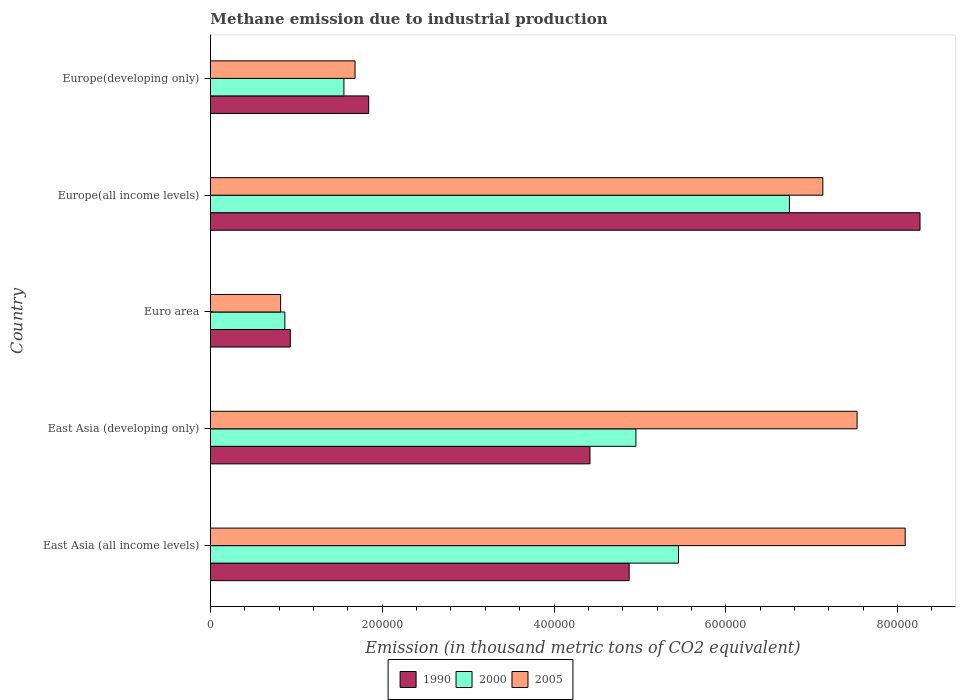How many different coloured bars are there?
Offer a terse response. 3. Are the number of bars on each tick of the Y-axis equal?
Offer a very short reply. Yes. How many bars are there on the 2nd tick from the top?
Offer a very short reply. 3. How many bars are there on the 1st tick from the bottom?
Your answer should be compact. 3. What is the label of the 2nd group of bars from the top?
Offer a very short reply. Europe(all income levels). What is the amount of methane emitted in 1990 in Europe(all income levels)?
Provide a short and direct response. 8.26e+05. Across all countries, what is the maximum amount of methane emitted in 1990?
Offer a terse response. 8.26e+05. Across all countries, what is the minimum amount of methane emitted in 2000?
Provide a short and direct response. 8.66e+04. In which country was the amount of methane emitted in 1990 maximum?
Your answer should be very brief. Europe(all income levels). What is the total amount of methane emitted in 2000 in the graph?
Make the answer very short. 1.96e+06. What is the difference between the amount of methane emitted in 2005 in Europe(all income levels) and that in Europe(developing only)?
Your answer should be compact. 5.45e+05. What is the difference between the amount of methane emitted in 1990 in Euro area and the amount of methane emitted in 2000 in East Asia (all income levels)?
Your answer should be compact. -4.52e+05. What is the average amount of methane emitted in 2000 per country?
Keep it short and to the point. 3.91e+05. What is the difference between the amount of methane emitted in 2005 and amount of methane emitted in 2000 in Euro area?
Your answer should be very brief. -4908.4. In how many countries, is the amount of methane emitted in 1990 greater than 680000 thousand metric tons?
Provide a short and direct response. 1. What is the ratio of the amount of methane emitted in 2000 in East Asia (developing only) to that in Europe(all income levels)?
Your answer should be very brief. 0.73. Is the difference between the amount of methane emitted in 2005 in East Asia (all income levels) and Europe(developing only) greater than the difference between the amount of methane emitted in 2000 in East Asia (all income levels) and Europe(developing only)?
Offer a terse response. Yes. What is the difference between the highest and the second highest amount of methane emitted in 2005?
Give a very brief answer. 5.60e+04. What is the difference between the highest and the lowest amount of methane emitted in 1990?
Your answer should be compact. 7.33e+05. In how many countries, is the amount of methane emitted in 2000 greater than the average amount of methane emitted in 2000 taken over all countries?
Offer a very short reply. 3. What does the 3rd bar from the bottom in Euro area represents?
Ensure brevity in your answer.  2005. How many bars are there?
Give a very brief answer. 15. What is the difference between two consecutive major ticks on the X-axis?
Keep it short and to the point. 2.00e+05. Are the values on the major ticks of X-axis written in scientific E-notation?
Offer a terse response. No. Does the graph contain any zero values?
Provide a succinct answer. No. Does the graph contain grids?
Offer a terse response. No. Where does the legend appear in the graph?
Provide a short and direct response. Bottom center. How many legend labels are there?
Make the answer very short. 3. What is the title of the graph?
Ensure brevity in your answer.  Methane emission due to industrial production. Does "1962" appear as one of the legend labels in the graph?
Give a very brief answer. No. What is the label or title of the X-axis?
Provide a succinct answer. Emission (in thousand metric tons of CO2 equivalent). What is the Emission (in thousand metric tons of CO2 equivalent) in 1990 in East Asia (all income levels)?
Keep it short and to the point. 4.88e+05. What is the Emission (in thousand metric tons of CO2 equivalent) of 2000 in East Asia (all income levels)?
Keep it short and to the point. 5.45e+05. What is the Emission (in thousand metric tons of CO2 equivalent) of 2005 in East Asia (all income levels)?
Provide a succinct answer. 8.09e+05. What is the Emission (in thousand metric tons of CO2 equivalent) in 1990 in East Asia (developing only)?
Keep it short and to the point. 4.42e+05. What is the Emission (in thousand metric tons of CO2 equivalent) in 2000 in East Asia (developing only)?
Provide a short and direct response. 4.95e+05. What is the Emission (in thousand metric tons of CO2 equivalent) of 2005 in East Asia (developing only)?
Keep it short and to the point. 7.53e+05. What is the Emission (in thousand metric tons of CO2 equivalent) of 1990 in Euro area?
Provide a succinct answer. 9.30e+04. What is the Emission (in thousand metric tons of CO2 equivalent) of 2000 in Euro area?
Provide a short and direct response. 8.66e+04. What is the Emission (in thousand metric tons of CO2 equivalent) in 2005 in Euro area?
Offer a terse response. 8.17e+04. What is the Emission (in thousand metric tons of CO2 equivalent) of 1990 in Europe(all income levels)?
Ensure brevity in your answer.  8.26e+05. What is the Emission (in thousand metric tons of CO2 equivalent) in 2000 in Europe(all income levels)?
Make the answer very short. 6.74e+05. What is the Emission (in thousand metric tons of CO2 equivalent) of 2005 in Europe(all income levels)?
Give a very brief answer. 7.13e+05. What is the Emission (in thousand metric tons of CO2 equivalent) of 1990 in Europe(developing only)?
Give a very brief answer. 1.84e+05. What is the Emission (in thousand metric tons of CO2 equivalent) of 2000 in Europe(developing only)?
Offer a terse response. 1.55e+05. What is the Emission (in thousand metric tons of CO2 equivalent) in 2005 in Europe(developing only)?
Provide a succinct answer. 1.68e+05. Across all countries, what is the maximum Emission (in thousand metric tons of CO2 equivalent) of 1990?
Provide a short and direct response. 8.26e+05. Across all countries, what is the maximum Emission (in thousand metric tons of CO2 equivalent) in 2000?
Offer a terse response. 6.74e+05. Across all countries, what is the maximum Emission (in thousand metric tons of CO2 equivalent) in 2005?
Your response must be concise. 8.09e+05. Across all countries, what is the minimum Emission (in thousand metric tons of CO2 equivalent) of 1990?
Keep it short and to the point. 9.30e+04. Across all countries, what is the minimum Emission (in thousand metric tons of CO2 equivalent) of 2000?
Offer a very short reply. 8.66e+04. Across all countries, what is the minimum Emission (in thousand metric tons of CO2 equivalent) in 2005?
Provide a short and direct response. 8.17e+04. What is the total Emission (in thousand metric tons of CO2 equivalent) in 1990 in the graph?
Ensure brevity in your answer.  2.03e+06. What is the total Emission (in thousand metric tons of CO2 equivalent) of 2000 in the graph?
Provide a succinct answer. 1.96e+06. What is the total Emission (in thousand metric tons of CO2 equivalent) of 2005 in the graph?
Give a very brief answer. 2.52e+06. What is the difference between the Emission (in thousand metric tons of CO2 equivalent) in 1990 in East Asia (all income levels) and that in East Asia (developing only)?
Offer a terse response. 4.56e+04. What is the difference between the Emission (in thousand metric tons of CO2 equivalent) in 2000 in East Asia (all income levels) and that in East Asia (developing only)?
Make the answer very short. 4.96e+04. What is the difference between the Emission (in thousand metric tons of CO2 equivalent) in 2005 in East Asia (all income levels) and that in East Asia (developing only)?
Your response must be concise. 5.60e+04. What is the difference between the Emission (in thousand metric tons of CO2 equivalent) of 1990 in East Asia (all income levels) and that in Euro area?
Ensure brevity in your answer.  3.95e+05. What is the difference between the Emission (in thousand metric tons of CO2 equivalent) in 2000 in East Asia (all income levels) and that in Euro area?
Give a very brief answer. 4.58e+05. What is the difference between the Emission (in thousand metric tons of CO2 equivalent) in 2005 in East Asia (all income levels) and that in Euro area?
Ensure brevity in your answer.  7.27e+05. What is the difference between the Emission (in thousand metric tons of CO2 equivalent) in 1990 in East Asia (all income levels) and that in Europe(all income levels)?
Your answer should be compact. -3.39e+05. What is the difference between the Emission (in thousand metric tons of CO2 equivalent) in 2000 in East Asia (all income levels) and that in Europe(all income levels)?
Provide a short and direct response. -1.29e+05. What is the difference between the Emission (in thousand metric tons of CO2 equivalent) of 2005 in East Asia (all income levels) and that in Europe(all income levels)?
Give a very brief answer. 9.59e+04. What is the difference between the Emission (in thousand metric tons of CO2 equivalent) in 1990 in East Asia (all income levels) and that in Europe(developing only)?
Offer a very short reply. 3.03e+05. What is the difference between the Emission (in thousand metric tons of CO2 equivalent) of 2000 in East Asia (all income levels) and that in Europe(developing only)?
Your answer should be compact. 3.90e+05. What is the difference between the Emission (in thousand metric tons of CO2 equivalent) in 2005 in East Asia (all income levels) and that in Europe(developing only)?
Your answer should be compact. 6.41e+05. What is the difference between the Emission (in thousand metric tons of CO2 equivalent) of 1990 in East Asia (developing only) and that in Euro area?
Provide a short and direct response. 3.49e+05. What is the difference between the Emission (in thousand metric tons of CO2 equivalent) in 2000 in East Asia (developing only) and that in Euro area?
Your answer should be very brief. 4.09e+05. What is the difference between the Emission (in thousand metric tons of CO2 equivalent) of 2005 in East Asia (developing only) and that in Euro area?
Provide a succinct answer. 6.71e+05. What is the difference between the Emission (in thousand metric tons of CO2 equivalent) in 1990 in East Asia (developing only) and that in Europe(all income levels)?
Your answer should be compact. -3.84e+05. What is the difference between the Emission (in thousand metric tons of CO2 equivalent) in 2000 in East Asia (developing only) and that in Europe(all income levels)?
Ensure brevity in your answer.  -1.79e+05. What is the difference between the Emission (in thousand metric tons of CO2 equivalent) of 2005 in East Asia (developing only) and that in Europe(all income levels)?
Your answer should be compact. 3.99e+04. What is the difference between the Emission (in thousand metric tons of CO2 equivalent) of 1990 in East Asia (developing only) and that in Europe(developing only)?
Keep it short and to the point. 2.58e+05. What is the difference between the Emission (in thousand metric tons of CO2 equivalent) of 2000 in East Asia (developing only) and that in Europe(developing only)?
Give a very brief answer. 3.40e+05. What is the difference between the Emission (in thousand metric tons of CO2 equivalent) in 2005 in East Asia (developing only) and that in Europe(developing only)?
Your answer should be very brief. 5.85e+05. What is the difference between the Emission (in thousand metric tons of CO2 equivalent) of 1990 in Euro area and that in Europe(all income levels)?
Make the answer very short. -7.33e+05. What is the difference between the Emission (in thousand metric tons of CO2 equivalent) in 2000 in Euro area and that in Europe(all income levels)?
Your response must be concise. -5.88e+05. What is the difference between the Emission (in thousand metric tons of CO2 equivalent) of 2005 in Euro area and that in Europe(all income levels)?
Your answer should be very brief. -6.31e+05. What is the difference between the Emission (in thousand metric tons of CO2 equivalent) in 1990 in Euro area and that in Europe(developing only)?
Provide a short and direct response. -9.13e+04. What is the difference between the Emission (in thousand metric tons of CO2 equivalent) in 2000 in Euro area and that in Europe(developing only)?
Ensure brevity in your answer.  -6.88e+04. What is the difference between the Emission (in thousand metric tons of CO2 equivalent) of 2005 in Euro area and that in Europe(developing only)?
Offer a very short reply. -8.66e+04. What is the difference between the Emission (in thousand metric tons of CO2 equivalent) of 1990 in Europe(all income levels) and that in Europe(developing only)?
Provide a short and direct response. 6.42e+05. What is the difference between the Emission (in thousand metric tons of CO2 equivalent) in 2000 in Europe(all income levels) and that in Europe(developing only)?
Your response must be concise. 5.19e+05. What is the difference between the Emission (in thousand metric tons of CO2 equivalent) of 2005 in Europe(all income levels) and that in Europe(developing only)?
Provide a succinct answer. 5.45e+05. What is the difference between the Emission (in thousand metric tons of CO2 equivalent) of 1990 in East Asia (all income levels) and the Emission (in thousand metric tons of CO2 equivalent) of 2000 in East Asia (developing only)?
Your answer should be very brief. -7879.1. What is the difference between the Emission (in thousand metric tons of CO2 equivalent) of 1990 in East Asia (all income levels) and the Emission (in thousand metric tons of CO2 equivalent) of 2005 in East Asia (developing only)?
Your response must be concise. -2.65e+05. What is the difference between the Emission (in thousand metric tons of CO2 equivalent) in 2000 in East Asia (all income levels) and the Emission (in thousand metric tons of CO2 equivalent) in 2005 in East Asia (developing only)?
Your response must be concise. -2.08e+05. What is the difference between the Emission (in thousand metric tons of CO2 equivalent) in 1990 in East Asia (all income levels) and the Emission (in thousand metric tons of CO2 equivalent) in 2000 in Euro area?
Your response must be concise. 4.01e+05. What is the difference between the Emission (in thousand metric tons of CO2 equivalent) of 1990 in East Asia (all income levels) and the Emission (in thousand metric tons of CO2 equivalent) of 2005 in Euro area?
Your response must be concise. 4.06e+05. What is the difference between the Emission (in thousand metric tons of CO2 equivalent) of 2000 in East Asia (all income levels) and the Emission (in thousand metric tons of CO2 equivalent) of 2005 in Euro area?
Keep it short and to the point. 4.63e+05. What is the difference between the Emission (in thousand metric tons of CO2 equivalent) in 1990 in East Asia (all income levels) and the Emission (in thousand metric tons of CO2 equivalent) in 2000 in Europe(all income levels)?
Ensure brevity in your answer.  -1.87e+05. What is the difference between the Emission (in thousand metric tons of CO2 equivalent) in 1990 in East Asia (all income levels) and the Emission (in thousand metric tons of CO2 equivalent) in 2005 in Europe(all income levels)?
Offer a terse response. -2.26e+05. What is the difference between the Emission (in thousand metric tons of CO2 equivalent) in 2000 in East Asia (all income levels) and the Emission (in thousand metric tons of CO2 equivalent) in 2005 in Europe(all income levels)?
Offer a very short reply. -1.68e+05. What is the difference between the Emission (in thousand metric tons of CO2 equivalent) in 1990 in East Asia (all income levels) and the Emission (in thousand metric tons of CO2 equivalent) in 2000 in Europe(developing only)?
Provide a short and direct response. 3.32e+05. What is the difference between the Emission (in thousand metric tons of CO2 equivalent) in 1990 in East Asia (all income levels) and the Emission (in thousand metric tons of CO2 equivalent) in 2005 in Europe(developing only)?
Keep it short and to the point. 3.19e+05. What is the difference between the Emission (in thousand metric tons of CO2 equivalent) in 2000 in East Asia (all income levels) and the Emission (in thousand metric tons of CO2 equivalent) in 2005 in Europe(developing only)?
Give a very brief answer. 3.77e+05. What is the difference between the Emission (in thousand metric tons of CO2 equivalent) in 1990 in East Asia (developing only) and the Emission (in thousand metric tons of CO2 equivalent) in 2000 in Euro area?
Provide a succinct answer. 3.55e+05. What is the difference between the Emission (in thousand metric tons of CO2 equivalent) of 1990 in East Asia (developing only) and the Emission (in thousand metric tons of CO2 equivalent) of 2005 in Euro area?
Make the answer very short. 3.60e+05. What is the difference between the Emission (in thousand metric tons of CO2 equivalent) of 2000 in East Asia (developing only) and the Emission (in thousand metric tons of CO2 equivalent) of 2005 in Euro area?
Keep it short and to the point. 4.14e+05. What is the difference between the Emission (in thousand metric tons of CO2 equivalent) in 1990 in East Asia (developing only) and the Emission (in thousand metric tons of CO2 equivalent) in 2000 in Europe(all income levels)?
Provide a succinct answer. -2.32e+05. What is the difference between the Emission (in thousand metric tons of CO2 equivalent) in 1990 in East Asia (developing only) and the Emission (in thousand metric tons of CO2 equivalent) in 2005 in Europe(all income levels)?
Make the answer very short. -2.71e+05. What is the difference between the Emission (in thousand metric tons of CO2 equivalent) of 2000 in East Asia (developing only) and the Emission (in thousand metric tons of CO2 equivalent) of 2005 in Europe(all income levels)?
Your response must be concise. -2.18e+05. What is the difference between the Emission (in thousand metric tons of CO2 equivalent) in 1990 in East Asia (developing only) and the Emission (in thousand metric tons of CO2 equivalent) in 2000 in Europe(developing only)?
Your answer should be very brief. 2.87e+05. What is the difference between the Emission (in thousand metric tons of CO2 equivalent) of 1990 in East Asia (developing only) and the Emission (in thousand metric tons of CO2 equivalent) of 2005 in Europe(developing only)?
Offer a terse response. 2.74e+05. What is the difference between the Emission (in thousand metric tons of CO2 equivalent) of 2000 in East Asia (developing only) and the Emission (in thousand metric tons of CO2 equivalent) of 2005 in Europe(developing only)?
Offer a terse response. 3.27e+05. What is the difference between the Emission (in thousand metric tons of CO2 equivalent) of 1990 in Euro area and the Emission (in thousand metric tons of CO2 equivalent) of 2000 in Europe(all income levels)?
Offer a terse response. -5.81e+05. What is the difference between the Emission (in thousand metric tons of CO2 equivalent) in 1990 in Euro area and the Emission (in thousand metric tons of CO2 equivalent) in 2005 in Europe(all income levels)?
Offer a terse response. -6.20e+05. What is the difference between the Emission (in thousand metric tons of CO2 equivalent) of 2000 in Euro area and the Emission (in thousand metric tons of CO2 equivalent) of 2005 in Europe(all income levels)?
Offer a terse response. -6.26e+05. What is the difference between the Emission (in thousand metric tons of CO2 equivalent) in 1990 in Euro area and the Emission (in thousand metric tons of CO2 equivalent) in 2000 in Europe(developing only)?
Keep it short and to the point. -6.24e+04. What is the difference between the Emission (in thousand metric tons of CO2 equivalent) of 1990 in Euro area and the Emission (in thousand metric tons of CO2 equivalent) of 2005 in Europe(developing only)?
Ensure brevity in your answer.  -7.54e+04. What is the difference between the Emission (in thousand metric tons of CO2 equivalent) in 2000 in Euro area and the Emission (in thousand metric tons of CO2 equivalent) in 2005 in Europe(developing only)?
Ensure brevity in your answer.  -8.17e+04. What is the difference between the Emission (in thousand metric tons of CO2 equivalent) of 1990 in Europe(all income levels) and the Emission (in thousand metric tons of CO2 equivalent) of 2000 in Europe(developing only)?
Your answer should be very brief. 6.71e+05. What is the difference between the Emission (in thousand metric tons of CO2 equivalent) of 1990 in Europe(all income levels) and the Emission (in thousand metric tons of CO2 equivalent) of 2005 in Europe(developing only)?
Make the answer very short. 6.58e+05. What is the difference between the Emission (in thousand metric tons of CO2 equivalent) of 2000 in Europe(all income levels) and the Emission (in thousand metric tons of CO2 equivalent) of 2005 in Europe(developing only)?
Your answer should be compact. 5.06e+05. What is the average Emission (in thousand metric tons of CO2 equivalent) of 1990 per country?
Provide a short and direct response. 4.07e+05. What is the average Emission (in thousand metric tons of CO2 equivalent) of 2000 per country?
Offer a very short reply. 3.91e+05. What is the average Emission (in thousand metric tons of CO2 equivalent) of 2005 per country?
Your answer should be very brief. 5.05e+05. What is the difference between the Emission (in thousand metric tons of CO2 equivalent) in 1990 and Emission (in thousand metric tons of CO2 equivalent) in 2000 in East Asia (all income levels)?
Your answer should be very brief. -5.74e+04. What is the difference between the Emission (in thousand metric tons of CO2 equivalent) in 1990 and Emission (in thousand metric tons of CO2 equivalent) in 2005 in East Asia (all income levels)?
Make the answer very short. -3.21e+05. What is the difference between the Emission (in thousand metric tons of CO2 equivalent) of 2000 and Emission (in thousand metric tons of CO2 equivalent) of 2005 in East Asia (all income levels)?
Offer a terse response. -2.64e+05. What is the difference between the Emission (in thousand metric tons of CO2 equivalent) of 1990 and Emission (in thousand metric tons of CO2 equivalent) of 2000 in East Asia (developing only)?
Your answer should be very brief. -5.35e+04. What is the difference between the Emission (in thousand metric tons of CO2 equivalent) of 1990 and Emission (in thousand metric tons of CO2 equivalent) of 2005 in East Asia (developing only)?
Your answer should be very brief. -3.11e+05. What is the difference between the Emission (in thousand metric tons of CO2 equivalent) of 2000 and Emission (in thousand metric tons of CO2 equivalent) of 2005 in East Asia (developing only)?
Ensure brevity in your answer.  -2.58e+05. What is the difference between the Emission (in thousand metric tons of CO2 equivalent) in 1990 and Emission (in thousand metric tons of CO2 equivalent) in 2000 in Euro area?
Offer a very short reply. 6366.1. What is the difference between the Emission (in thousand metric tons of CO2 equivalent) of 1990 and Emission (in thousand metric tons of CO2 equivalent) of 2005 in Euro area?
Offer a very short reply. 1.13e+04. What is the difference between the Emission (in thousand metric tons of CO2 equivalent) of 2000 and Emission (in thousand metric tons of CO2 equivalent) of 2005 in Euro area?
Your answer should be compact. 4908.4. What is the difference between the Emission (in thousand metric tons of CO2 equivalent) of 1990 and Emission (in thousand metric tons of CO2 equivalent) of 2000 in Europe(all income levels)?
Offer a terse response. 1.52e+05. What is the difference between the Emission (in thousand metric tons of CO2 equivalent) of 1990 and Emission (in thousand metric tons of CO2 equivalent) of 2005 in Europe(all income levels)?
Keep it short and to the point. 1.13e+05. What is the difference between the Emission (in thousand metric tons of CO2 equivalent) of 2000 and Emission (in thousand metric tons of CO2 equivalent) of 2005 in Europe(all income levels)?
Provide a short and direct response. -3.89e+04. What is the difference between the Emission (in thousand metric tons of CO2 equivalent) in 1990 and Emission (in thousand metric tons of CO2 equivalent) in 2000 in Europe(developing only)?
Your answer should be compact. 2.88e+04. What is the difference between the Emission (in thousand metric tons of CO2 equivalent) of 1990 and Emission (in thousand metric tons of CO2 equivalent) of 2005 in Europe(developing only)?
Ensure brevity in your answer.  1.59e+04. What is the difference between the Emission (in thousand metric tons of CO2 equivalent) of 2000 and Emission (in thousand metric tons of CO2 equivalent) of 2005 in Europe(developing only)?
Offer a very short reply. -1.30e+04. What is the ratio of the Emission (in thousand metric tons of CO2 equivalent) in 1990 in East Asia (all income levels) to that in East Asia (developing only)?
Your answer should be very brief. 1.1. What is the ratio of the Emission (in thousand metric tons of CO2 equivalent) in 2005 in East Asia (all income levels) to that in East Asia (developing only)?
Your answer should be compact. 1.07. What is the ratio of the Emission (in thousand metric tons of CO2 equivalent) in 1990 in East Asia (all income levels) to that in Euro area?
Offer a terse response. 5.24. What is the ratio of the Emission (in thousand metric tons of CO2 equivalent) of 2000 in East Asia (all income levels) to that in Euro area?
Provide a succinct answer. 6.29. What is the ratio of the Emission (in thousand metric tons of CO2 equivalent) of 2005 in East Asia (all income levels) to that in Euro area?
Ensure brevity in your answer.  9.9. What is the ratio of the Emission (in thousand metric tons of CO2 equivalent) of 1990 in East Asia (all income levels) to that in Europe(all income levels)?
Make the answer very short. 0.59. What is the ratio of the Emission (in thousand metric tons of CO2 equivalent) in 2000 in East Asia (all income levels) to that in Europe(all income levels)?
Provide a succinct answer. 0.81. What is the ratio of the Emission (in thousand metric tons of CO2 equivalent) in 2005 in East Asia (all income levels) to that in Europe(all income levels)?
Your response must be concise. 1.13. What is the ratio of the Emission (in thousand metric tons of CO2 equivalent) of 1990 in East Asia (all income levels) to that in Europe(developing only)?
Provide a short and direct response. 2.65. What is the ratio of the Emission (in thousand metric tons of CO2 equivalent) in 2000 in East Asia (all income levels) to that in Europe(developing only)?
Give a very brief answer. 3.51. What is the ratio of the Emission (in thousand metric tons of CO2 equivalent) in 2005 in East Asia (all income levels) to that in Europe(developing only)?
Offer a very short reply. 4.81. What is the ratio of the Emission (in thousand metric tons of CO2 equivalent) in 1990 in East Asia (developing only) to that in Euro area?
Your response must be concise. 4.75. What is the ratio of the Emission (in thousand metric tons of CO2 equivalent) in 2000 in East Asia (developing only) to that in Euro area?
Keep it short and to the point. 5.72. What is the ratio of the Emission (in thousand metric tons of CO2 equivalent) of 2005 in East Asia (developing only) to that in Euro area?
Ensure brevity in your answer.  9.22. What is the ratio of the Emission (in thousand metric tons of CO2 equivalent) in 1990 in East Asia (developing only) to that in Europe(all income levels)?
Your answer should be very brief. 0.53. What is the ratio of the Emission (in thousand metric tons of CO2 equivalent) of 2000 in East Asia (developing only) to that in Europe(all income levels)?
Offer a terse response. 0.73. What is the ratio of the Emission (in thousand metric tons of CO2 equivalent) in 2005 in East Asia (developing only) to that in Europe(all income levels)?
Provide a succinct answer. 1.06. What is the ratio of the Emission (in thousand metric tons of CO2 equivalent) of 1990 in East Asia (developing only) to that in Europe(developing only)?
Offer a very short reply. 2.4. What is the ratio of the Emission (in thousand metric tons of CO2 equivalent) of 2000 in East Asia (developing only) to that in Europe(developing only)?
Provide a short and direct response. 3.19. What is the ratio of the Emission (in thousand metric tons of CO2 equivalent) in 2005 in East Asia (developing only) to that in Europe(developing only)?
Offer a terse response. 4.47. What is the ratio of the Emission (in thousand metric tons of CO2 equivalent) in 1990 in Euro area to that in Europe(all income levels)?
Offer a terse response. 0.11. What is the ratio of the Emission (in thousand metric tons of CO2 equivalent) in 2000 in Euro area to that in Europe(all income levels)?
Make the answer very short. 0.13. What is the ratio of the Emission (in thousand metric tons of CO2 equivalent) in 2005 in Euro area to that in Europe(all income levels)?
Give a very brief answer. 0.11. What is the ratio of the Emission (in thousand metric tons of CO2 equivalent) of 1990 in Euro area to that in Europe(developing only)?
Give a very brief answer. 0.5. What is the ratio of the Emission (in thousand metric tons of CO2 equivalent) of 2000 in Euro area to that in Europe(developing only)?
Your answer should be compact. 0.56. What is the ratio of the Emission (in thousand metric tons of CO2 equivalent) of 2005 in Euro area to that in Europe(developing only)?
Offer a very short reply. 0.49. What is the ratio of the Emission (in thousand metric tons of CO2 equivalent) of 1990 in Europe(all income levels) to that in Europe(developing only)?
Offer a terse response. 4.48. What is the ratio of the Emission (in thousand metric tons of CO2 equivalent) in 2000 in Europe(all income levels) to that in Europe(developing only)?
Give a very brief answer. 4.34. What is the ratio of the Emission (in thousand metric tons of CO2 equivalent) in 2005 in Europe(all income levels) to that in Europe(developing only)?
Keep it short and to the point. 4.24. What is the difference between the highest and the second highest Emission (in thousand metric tons of CO2 equivalent) in 1990?
Make the answer very short. 3.39e+05. What is the difference between the highest and the second highest Emission (in thousand metric tons of CO2 equivalent) in 2000?
Make the answer very short. 1.29e+05. What is the difference between the highest and the second highest Emission (in thousand metric tons of CO2 equivalent) in 2005?
Your response must be concise. 5.60e+04. What is the difference between the highest and the lowest Emission (in thousand metric tons of CO2 equivalent) of 1990?
Your answer should be compact. 7.33e+05. What is the difference between the highest and the lowest Emission (in thousand metric tons of CO2 equivalent) of 2000?
Provide a short and direct response. 5.88e+05. What is the difference between the highest and the lowest Emission (in thousand metric tons of CO2 equivalent) in 2005?
Provide a short and direct response. 7.27e+05. 